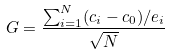<formula> <loc_0><loc_0><loc_500><loc_500>G = \frac { \sum _ { i = 1 } ^ { N } ( c _ { i } - c _ { 0 } ) / e _ { i } } { \sqrt { N } }</formula> 